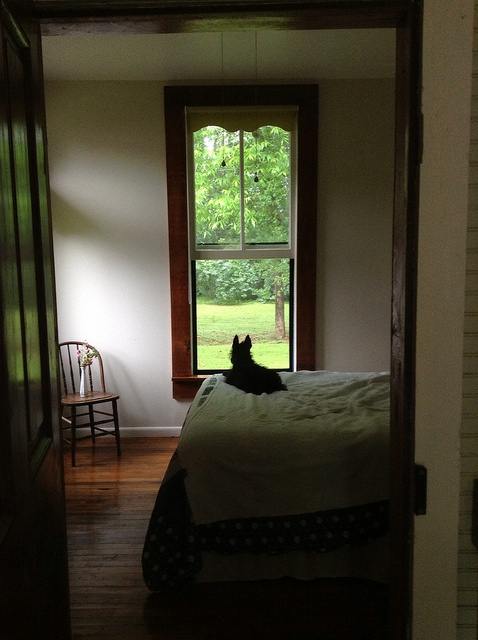Describe the objects in this image and their specific colors. I can see bed in black, darkgreen, and gray tones, chair in black, gray, darkgray, and lightgray tones, dog in black, gray, darkgreen, and khaki tones, and vase in black, lightgray, gray, and darkgray tones in this image. 